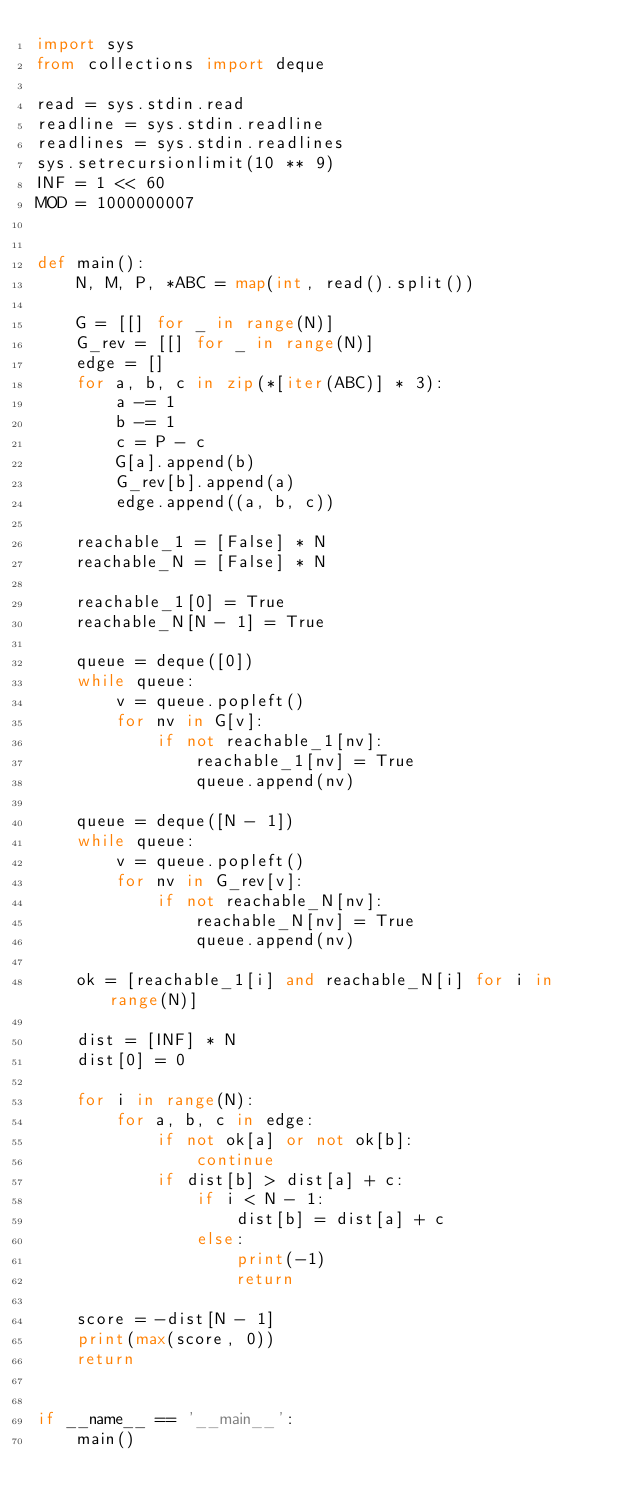<code> <loc_0><loc_0><loc_500><loc_500><_Python_>import sys
from collections import deque

read = sys.stdin.read
readline = sys.stdin.readline
readlines = sys.stdin.readlines
sys.setrecursionlimit(10 ** 9)
INF = 1 << 60
MOD = 1000000007


def main():
    N, M, P, *ABC = map(int, read().split())

    G = [[] for _ in range(N)]
    G_rev = [[] for _ in range(N)]
    edge = []
    for a, b, c in zip(*[iter(ABC)] * 3):
        a -= 1
        b -= 1
        c = P - c
        G[a].append(b)
        G_rev[b].append(a)
        edge.append((a, b, c))

    reachable_1 = [False] * N
    reachable_N = [False] * N

    reachable_1[0] = True
    reachable_N[N - 1] = True

    queue = deque([0])
    while queue:
        v = queue.popleft()
        for nv in G[v]:
            if not reachable_1[nv]:
                reachable_1[nv] = True
                queue.append(nv)

    queue = deque([N - 1])
    while queue:
        v = queue.popleft()
        for nv in G_rev[v]:
            if not reachable_N[nv]:
                reachable_N[nv] = True
                queue.append(nv)

    ok = [reachable_1[i] and reachable_N[i] for i in range(N)]

    dist = [INF] * N
    dist[0] = 0

    for i in range(N):
        for a, b, c in edge:
            if not ok[a] or not ok[b]:
                continue
            if dist[b] > dist[a] + c:
                if i < N - 1:
                    dist[b] = dist[a] + c
                else:
                    print(-1)
                    return

    score = -dist[N - 1]
    print(max(score, 0))
    return


if __name__ == '__main__':
    main()
</code> 